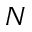<formula> <loc_0><loc_0><loc_500><loc_500>N</formula> 